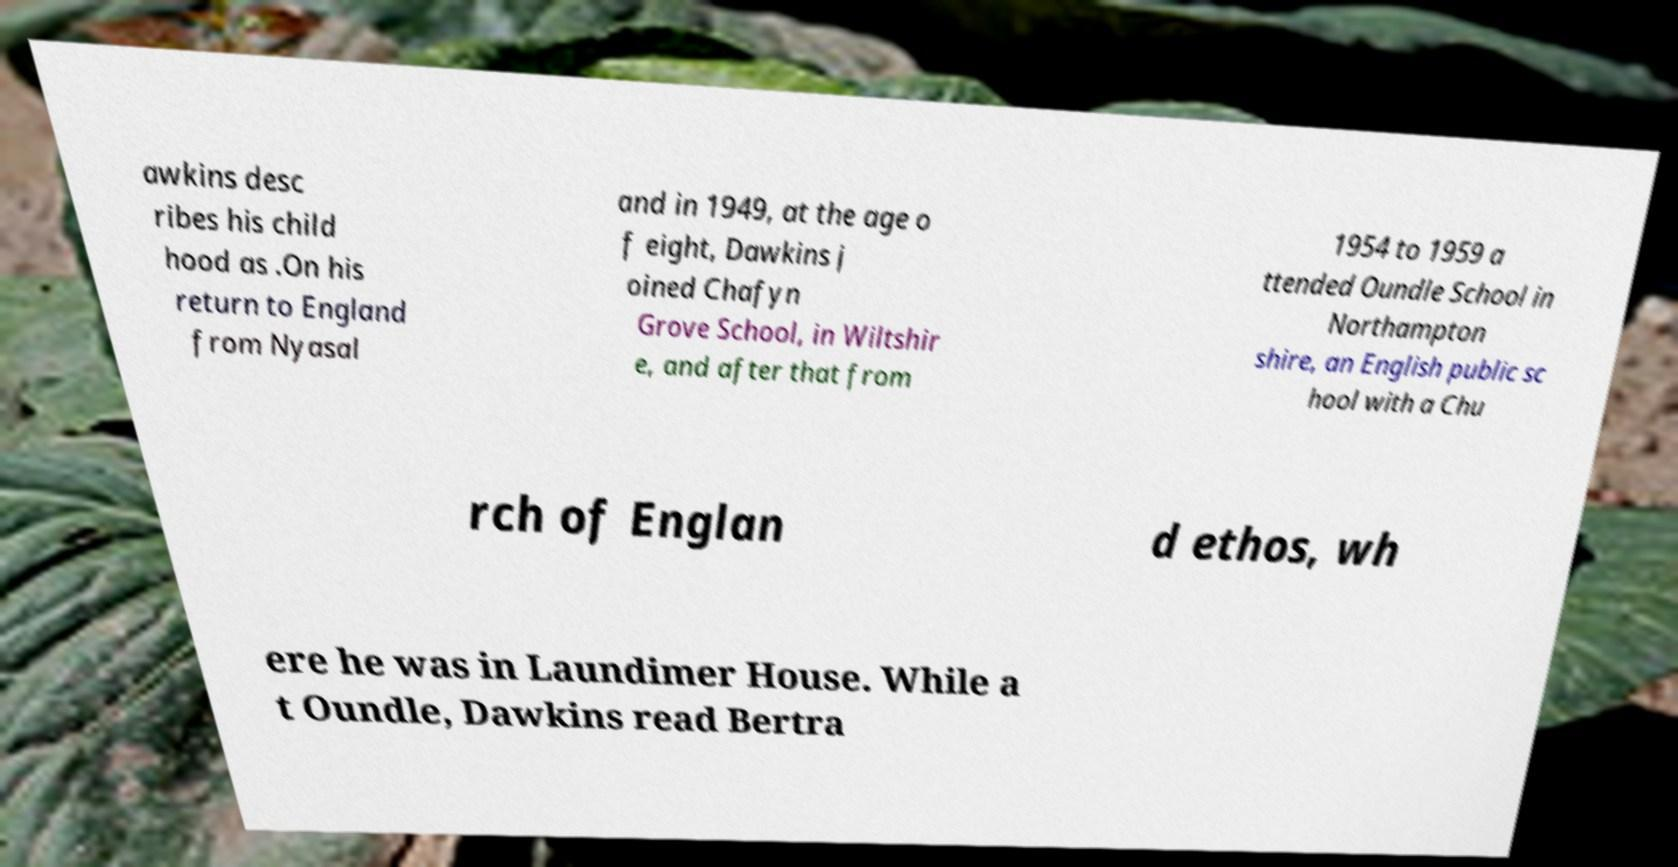What messages or text are displayed in this image? I need them in a readable, typed format. awkins desc ribes his child hood as .On his return to England from Nyasal and in 1949, at the age o f eight, Dawkins j oined Chafyn Grove School, in Wiltshir e, and after that from 1954 to 1959 a ttended Oundle School in Northampton shire, an English public sc hool with a Chu rch of Englan d ethos, wh ere he was in Laundimer House. While a t Oundle, Dawkins read Bertra 